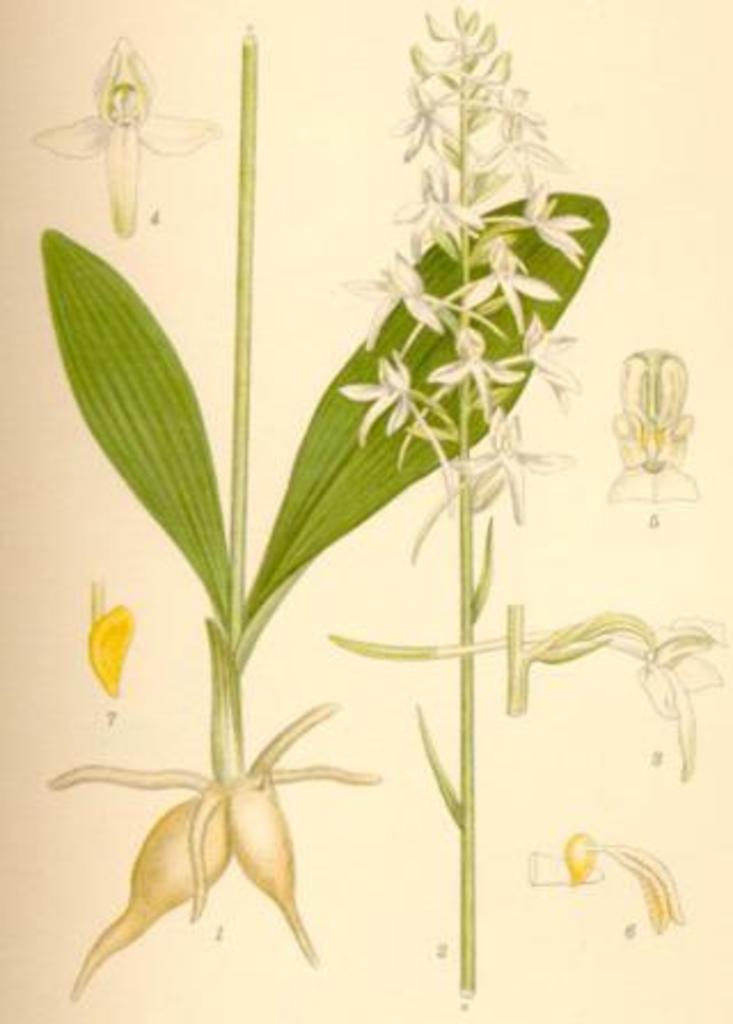Could you give a brief overview of what you see in this image? This is a page and in this page we can see flowers and leaves. 